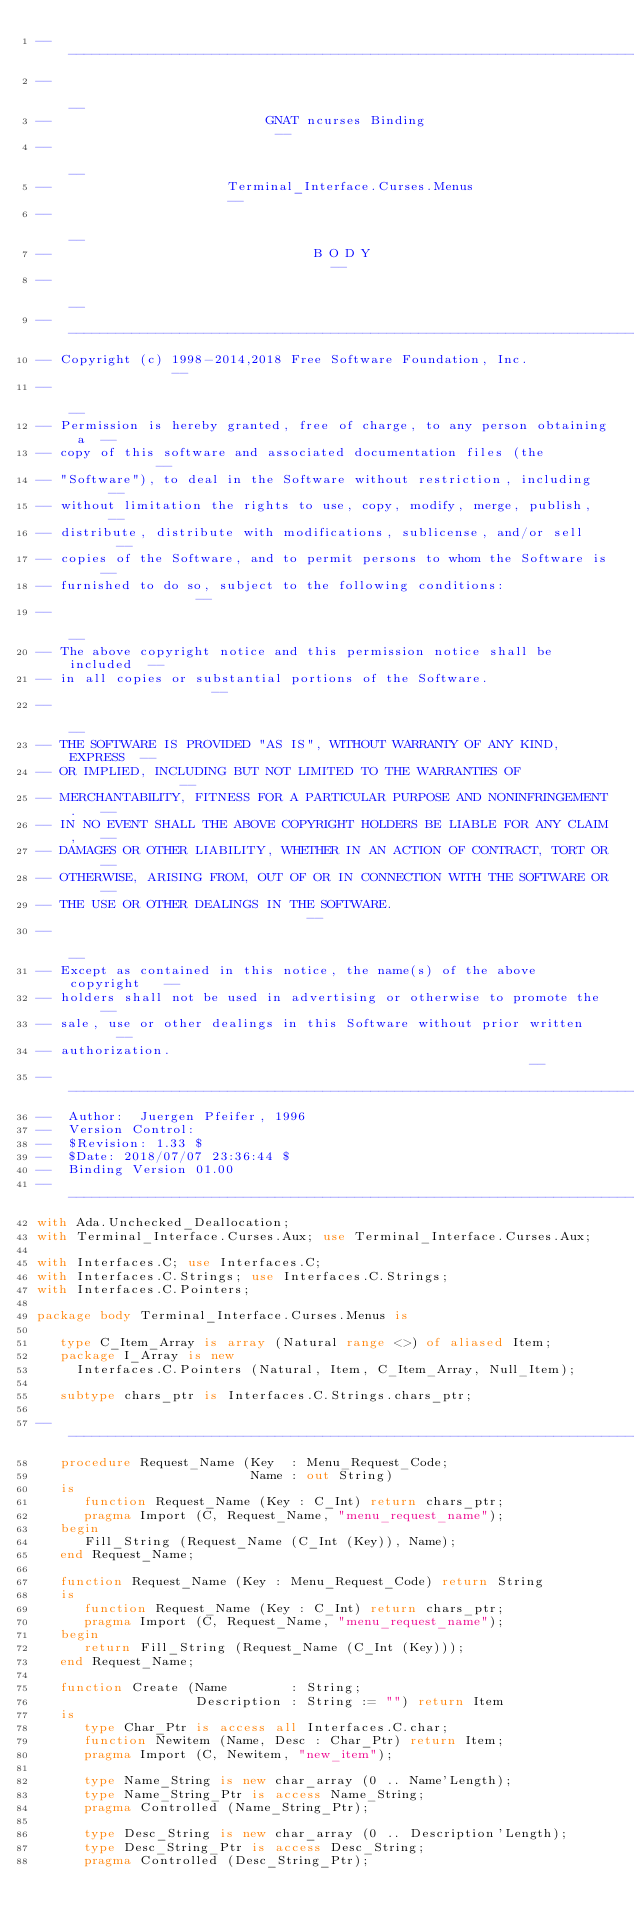<code> <loc_0><loc_0><loc_500><loc_500><_Ada_>------------------------------------------------------------------------------
--                                                                          --
--                           GNAT ncurses Binding                           --
--                                                                          --
--                      Terminal_Interface.Curses.Menus                     --
--                                                                          --
--                                 B O D Y                                  --
--                                                                          --
------------------------------------------------------------------------------
-- Copyright (c) 1998-2014,2018 Free Software Foundation, Inc.              --
--                                                                          --
-- Permission is hereby granted, free of charge, to any person obtaining a  --
-- copy of this software and associated documentation files (the            --
-- "Software"), to deal in the Software without restriction, including      --
-- without limitation the rights to use, copy, modify, merge, publish,      --
-- distribute, distribute with modifications, sublicense, and/or sell       --
-- copies of the Software, and to permit persons to whom the Software is    --
-- furnished to do so, subject to the following conditions:                 --
--                                                                          --
-- The above copyright notice and this permission notice shall be included  --
-- in all copies or substantial portions of the Software.                   --
--                                                                          --
-- THE SOFTWARE IS PROVIDED "AS IS", WITHOUT WARRANTY OF ANY KIND, EXPRESS  --
-- OR IMPLIED, INCLUDING BUT NOT LIMITED TO THE WARRANTIES OF               --
-- MERCHANTABILITY, FITNESS FOR A PARTICULAR PURPOSE AND NONINFRINGEMENT.   --
-- IN NO EVENT SHALL THE ABOVE COPYRIGHT HOLDERS BE LIABLE FOR ANY CLAIM,   --
-- DAMAGES OR OTHER LIABILITY, WHETHER IN AN ACTION OF CONTRACT, TORT OR    --
-- OTHERWISE, ARISING FROM, OUT OF OR IN CONNECTION WITH THE SOFTWARE OR    --
-- THE USE OR OTHER DEALINGS IN THE SOFTWARE.                               --
--                                                                          --
-- Except as contained in this notice, the name(s) of the above copyright   --
-- holders shall not be used in advertising or otherwise to promote the     --
-- sale, use or other dealings in this Software without prior written       --
-- authorization.                                                           --
------------------------------------------------------------------------------
--  Author:  Juergen Pfeifer, 1996
--  Version Control:
--  $Revision: 1.33 $
--  $Date: 2018/07/07 23:36:44 $
--  Binding Version 01.00
------------------------------------------------------------------------------
with Ada.Unchecked_Deallocation;
with Terminal_Interface.Curses.Aux; use Terminal_Interface.Curses.Aux;

with Interfaces.C; use Interfaces.C;
with Interfaces.C.Strings; use Interfaces.C.Strings;
with Interfaces.C.Pointers;

package body Terminal_Interface.Curses.Menus is

   type C_Item_Array is array (Natural range <>) of aliased Item;
   package I_Array is new
     Interfaces.C.Pointers (Natural, Item, C_Item_Array, Null_Item);

   subtype chars_ptr is Interfaces.C.Strings.chars_ptr;

------------------------------------------------------------------------------
   procedure Request_Name (Key  : Menu_Request_Code;
                           Name : out String)
   is
      function Request_Name (Key : C_Int) return chars_ptr;
      pragma Import (C, Request_Name, "menu_request_name");
   begin
      Fill_String (Request_Name (C_Int (Key)), Name);
   end Request_Name;

   function Request_Name (Key : Menu_Request_Code) return String
   is
      function Request_Name (Key : C_Int) return chars_ptr;
      pragma Import (C, Request_Name, "menu_request_name");
   begin
      return Fill_String (Request_Name (C_Int (Key)));
   end Request_Name;

   function Create (Name        : String;
                    Description : String := "") return Item
   is
      type Char_Ptr is access all Interfaces.C.char;
      function Newitem (Name, Desc : Char_Ptr) return Item;
      pragma Import (C, Newitem, "new_item");

      type Name_String is new char_array (0 .. Name'Length);
      type Name_String_Ptr is access Name_String;
      pragma Controlled (Name_String_Ptr);

      type Desc_String is new char_array (0 .. Description'Length);
      type Desc_String_Ptr is access Desc_String;
      pragma Controlled (Desc_String_Ptr);
</code> 